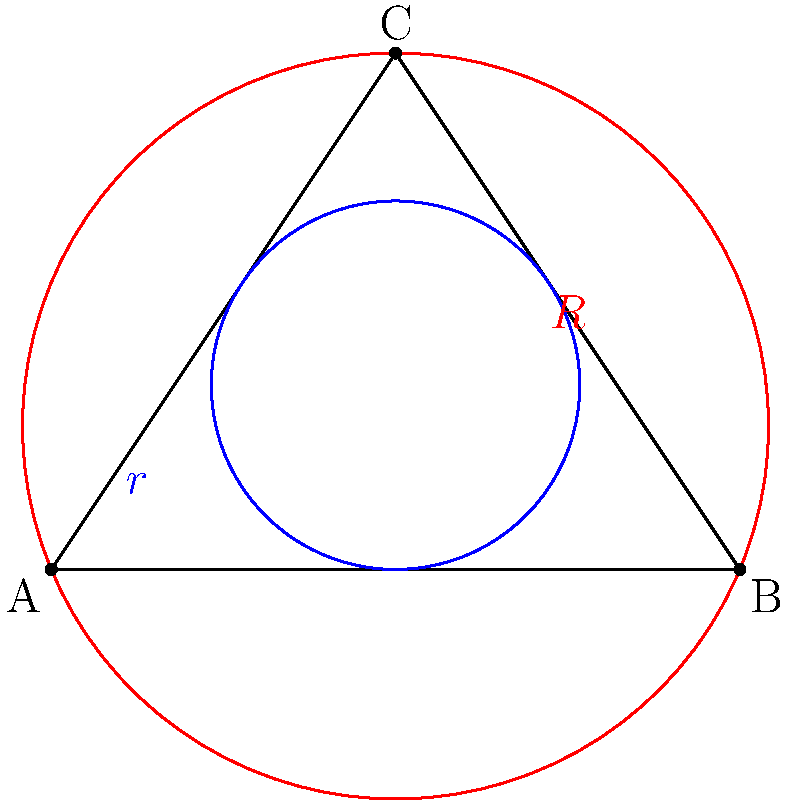In a sculpture inspired by nested circles, an artist creates a triangle with an inscribed and circumscribed circle. If the radius of the inscribed circle is $r$ and the radius of the circumscribed circle is $R$, what is the relationship between $r$, $R$, and the area of the triangle ($A$)? Let's approach this step-by-step:

1) First, recall the formula for the area of a triangle using the semiperimeter:
   $A = rs$, where $s$ is the semiperimeter.

2) Now, remember the formula for the area of a triangle using the circumradius:
   $A = \frac{abc}{4R}$, where $a$, $b$, and $c$ are the side lengths.

3) Since both formulas represent the same area, we can equate them:
   $rs = \frac{abc}{4R}$

4) The semiperimeter $s$ can be written as $s = \frac{a+b+c}{2}$

5) Substituting this into our equation:
   $r(\frac{a+b+c}{2}) = \frac{abc}{4R}$

6) Simplifying:
   $2rR(a+b+c) = abc$

7) This is the relationship between $r$, $R$, and the sides of the triangle.

8) To relate this to the area, we can use the formula from step 2:
   $A = \frac{abc}{4R}$

9) Substituting this into our equation from step 6:
   $2rR(a+b+c) = 4AR$

10) Simplifying:
    $r(a+b+c) = 2A$

This final equation relates $r$, $R$, and $A$.
Answer: $r(a+b+c) = 2A$ and $R = \frac{abc}{4A}$ 